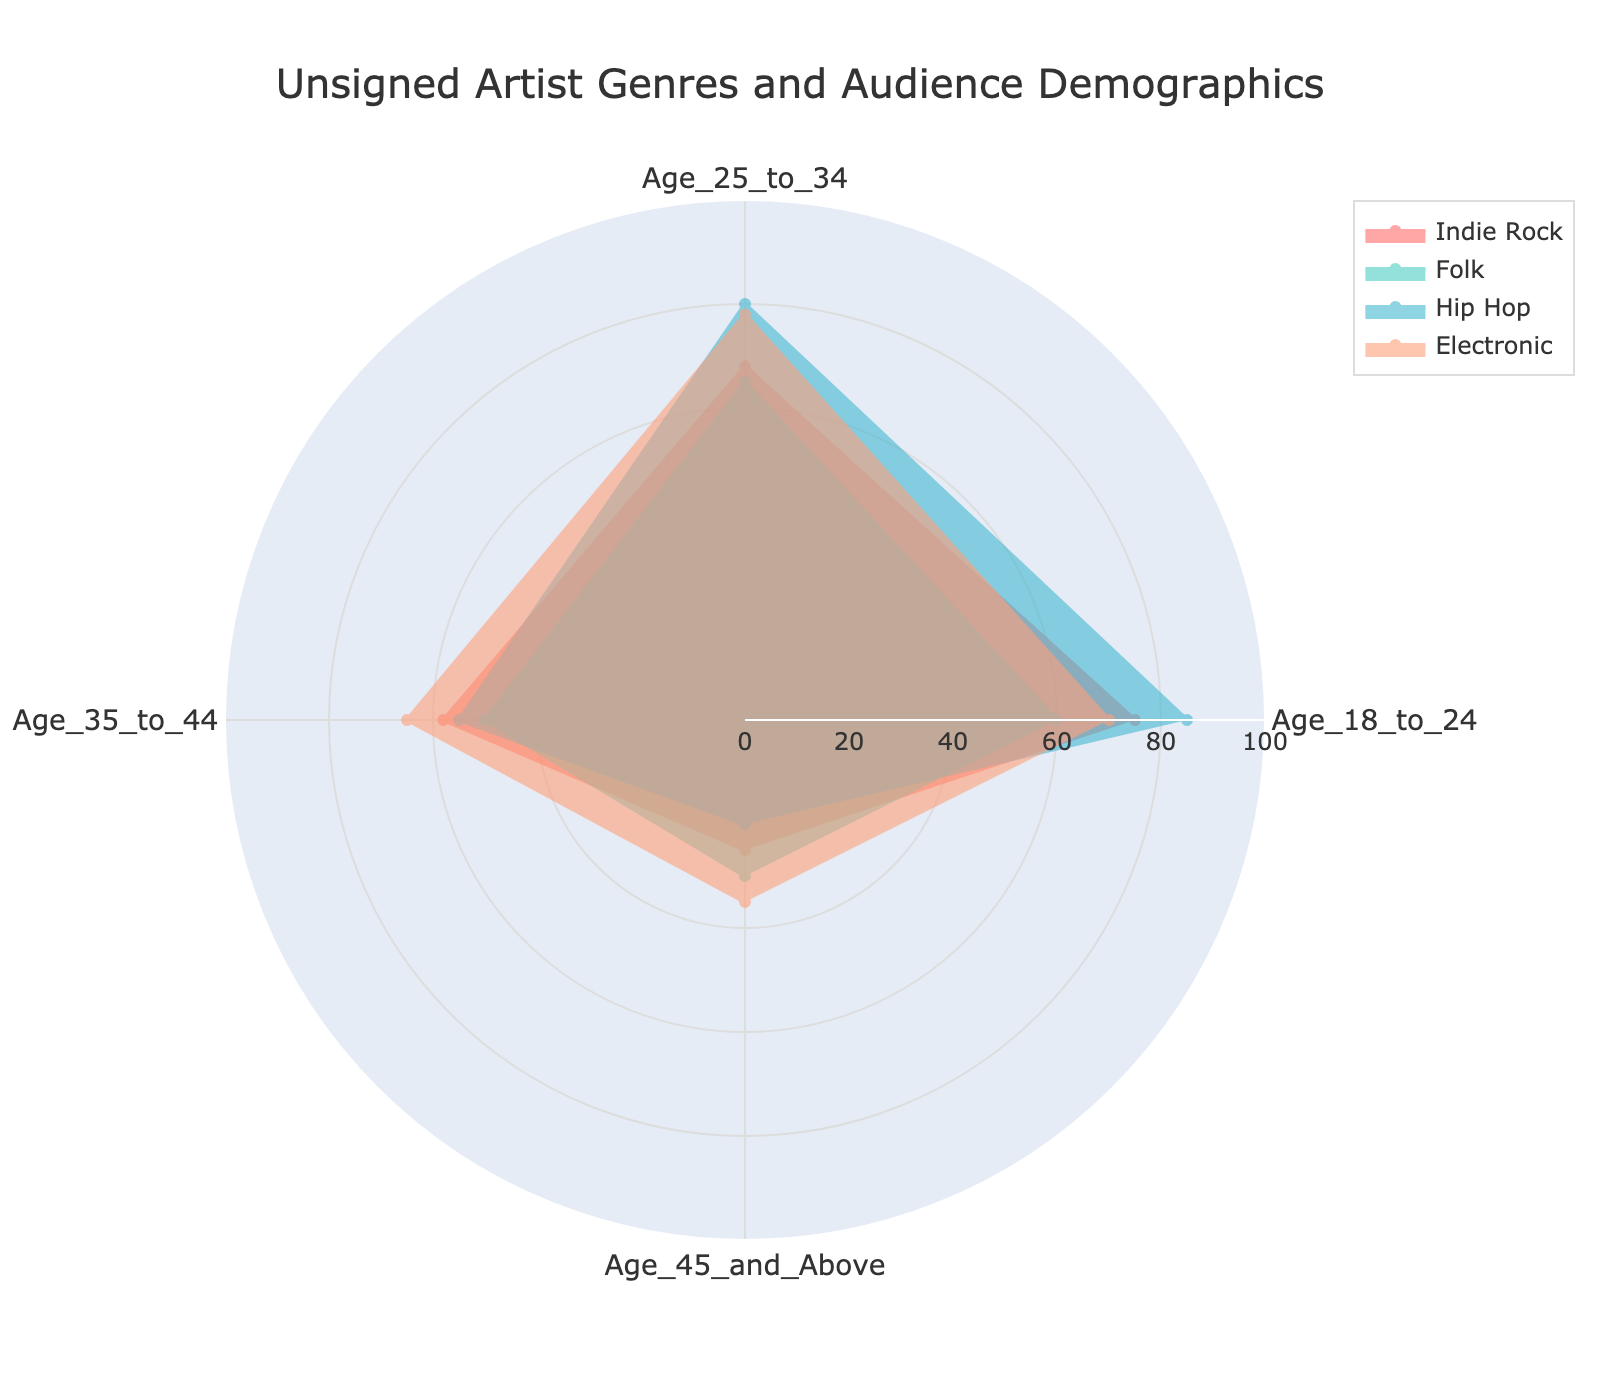What genre has the highest percentage of listeners aged 18 to 24? The radar chart shows various genres and corresponding audience percentages for different age groups. Looking at the "18 to 24" category, Hip Hop has the highest percentage, represented by the furthest extending point in that category.
Answer: Hip Hop Which genre has the smallest audience in the "45 and Above" age category? By observing the "45 and Above" category, the points representing each genre's audience percentage are visible. Hip Hop has the lowest value in this age group.
Answer: Hip Hop How does the audience of Indie Rock compare to that of Electronic in the "25 to 34" age group? Looking at the points for Indie Rock and Electronic in the "25 to 34" age group, the chart shows that Indie Rock has a value of 68 whereas Electronic has a value of 78.
Answer: Indie Rock is lower What's the average audience percentage for Folk across all age groups? To find the average, sum the values for Folk across all age groups: 60 (18 to 24) + 65 (25 to 34) + 50 (35 to 44) + 30 (45 and Above) = 205. Now, divide by the number of age groups, which is 4. 205 / 4 = 51.25.
Answer: 51.25 Which genres have a higher percentage of listeners aged 35 to 44 compared to aged 18 to 24? Comparing the values for the genres in the "35 to 44" and "18 to 24" categories, only Electronic shows a higher percentage in "35 to 44" (65) than in "18 to 24" (70).
Answer: None What is the difference in audience percentage between Hip Hop and Folk in the "25 to 34" age group? Hip Hop's audience in the "25 to 34" age group is 80, while Folk's is 65. The difference is 80 - 65 = 15.
Answer: 15 Which age group has the most even distribution of audience percentages across all genres? Examining the radar chart, the "35 to 44" age group shows values of 58, 50, 55, and 65 for Indie Rock, Folk, Hip Hop, and Electronic, respectively. These values are the closest to each other.
Answer: 35 to 44 What trend can you observe about the audience demographics for Indie Rock as the age increases? As the age groups increase from 18 to 24 to 45 and Above, the audience percentage for Indie Rock decreases: 75 (18 to 24), 68 (25 to 34), 58 (35 to 44), and 25 (45 and Above).
Answer: Decreases How does Folk compare to other genres in the "45 and Above" age group? By observing the "45 and Above" category, Folk has 30%, which is higher than Hip Hop (20%) and Indie Rock (25%) but lower than Electronic (35%).
Answer: Second highest Calculate the total combined audience percentage for Electronic across all age groups. Summing the values for Electronic across all age groups: 70 (18 to 24) + 78 (25 to 34) + 65 (35 to 44) + 35 (45 and Above) = 248.
Answer: 248 